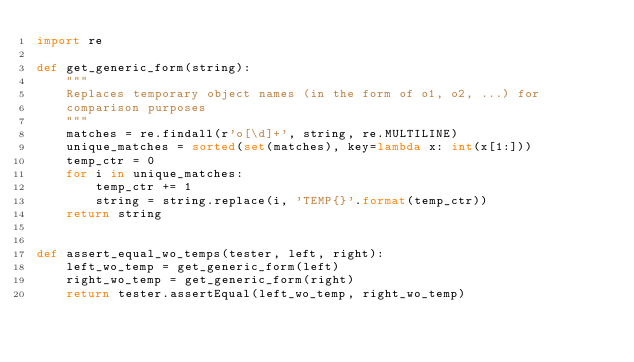<code> <loc_0><loc_0><loc_500><loc_500><_Python_>import re

def get_generic_form(string):
    """
    Replaces temporary object names (in the form of o1, o2, ...) for
    comparison purposes
    """
    matches = re.findall(r'o[\d]+', string, re.MULTILINE)
    unique_matches = sorted(set(matches), key=lambda x: int(x[1:]))
    temp_ctr = 0
    for i in unique_matches:
        temp_ctr += 1
        string = string.replace(i, 'TEMP{}'.format(temp_ctr))
    return string


def assert_equal_wo_temps(tester, left, right):
    left_wo_temp = get_generic_form(left)
    right_wo_temp = get_generic_form(right)
    return tester.assertEqual(left_wo_temp, right_wo_temp)
</code> 